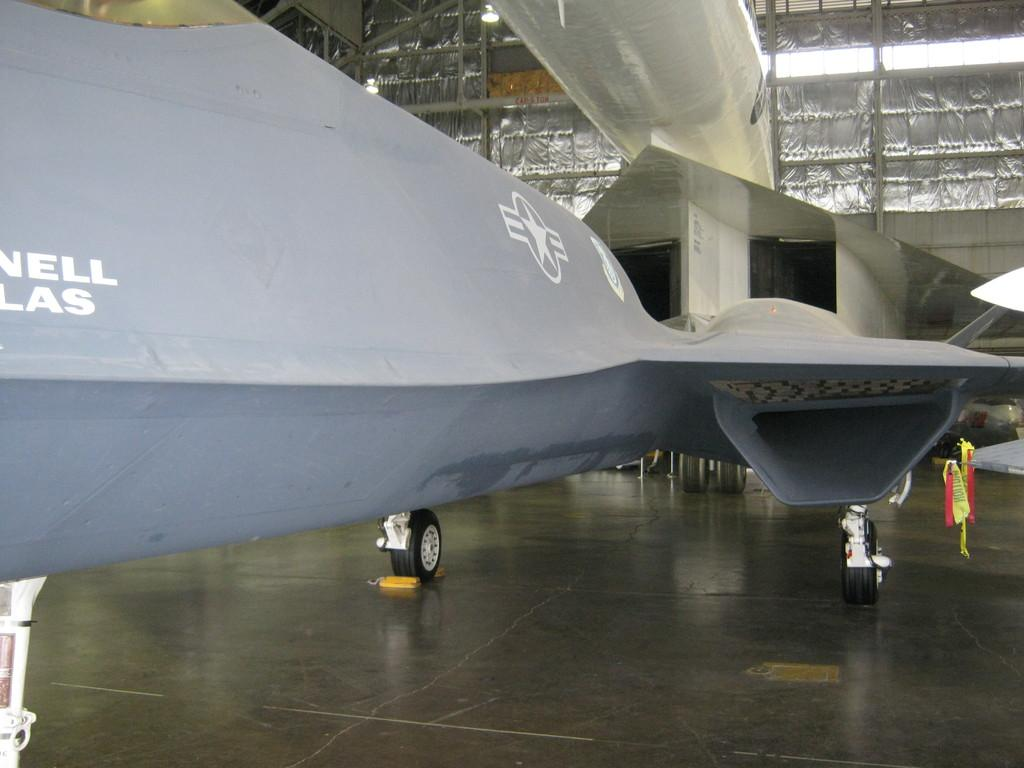What is the main subject of the image? The main subject of the image is an airplane. What type of doctor is examining the paint on the airplane in the image? There is no doctor or paint present in the image; it only features an airplane. Is the airplane leaking oil in the image? There is no indication of oil or any leakage in the image. 